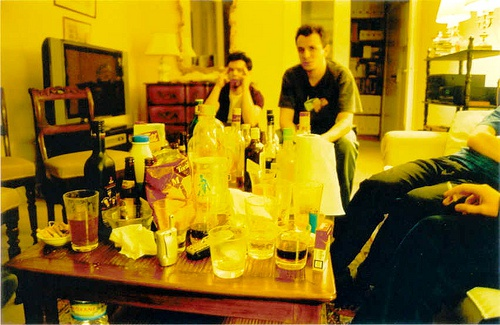Describe the objects in this image and their specific colors. I can see dining table in khaki, black, orange, red, and brown tones, people in khaki, black, olive, and orange tones, people in khaki, black, orange, red, and gold tones, people in khaki, black, orange, gold, and olive tones, and tv in khaki, black, maroon, and olive tones in this image. 